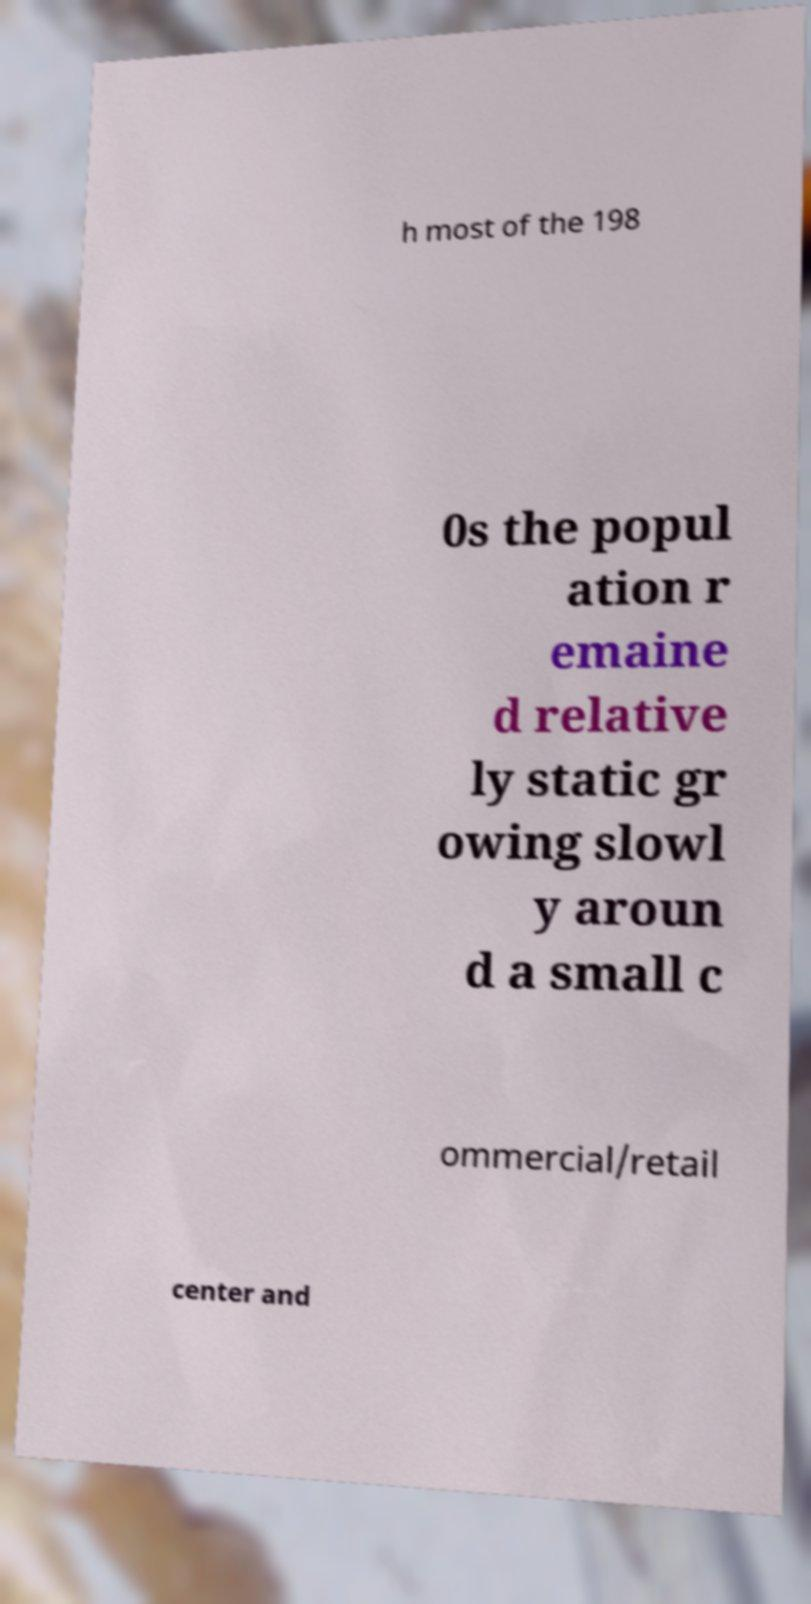Could you assist in decoding the text presented in this image and type it out clearly? h most of the 198 0s the popul ation r emaine d relative ly static gr owing slowl y aroun d a small c ommercial/retail center and 